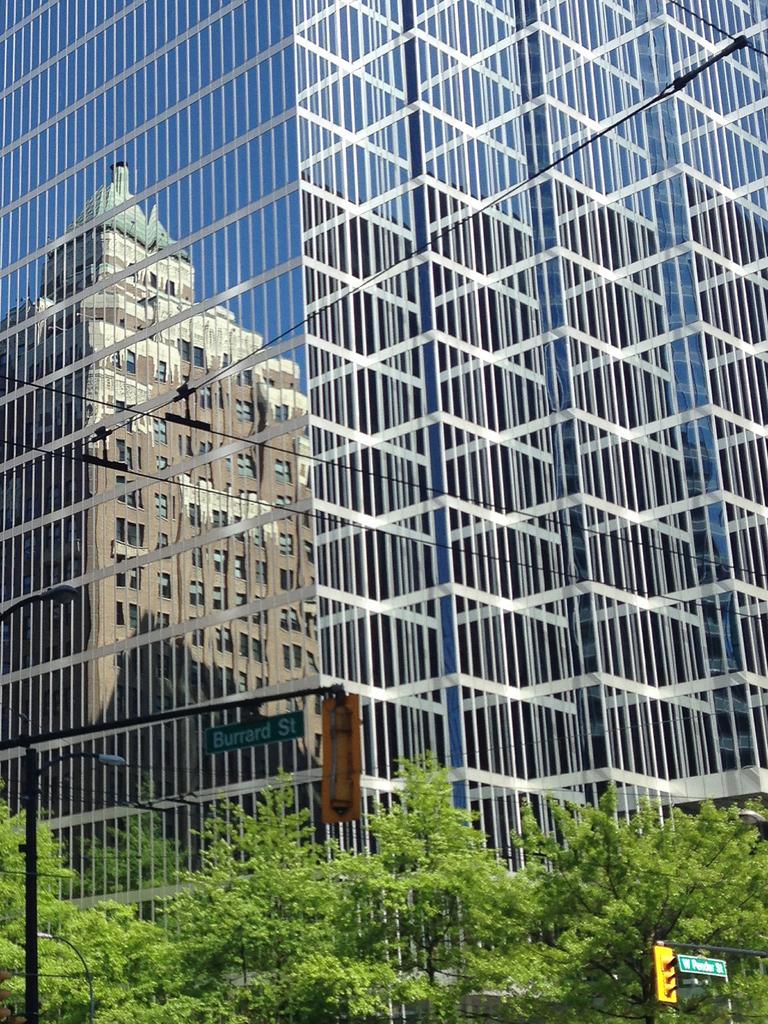In one or two sentences, can you explain what this image depicts? In this image I can see a building. On the left side, I can see the reflection of a building on the glass. At the bottom there are some trees and poles. 